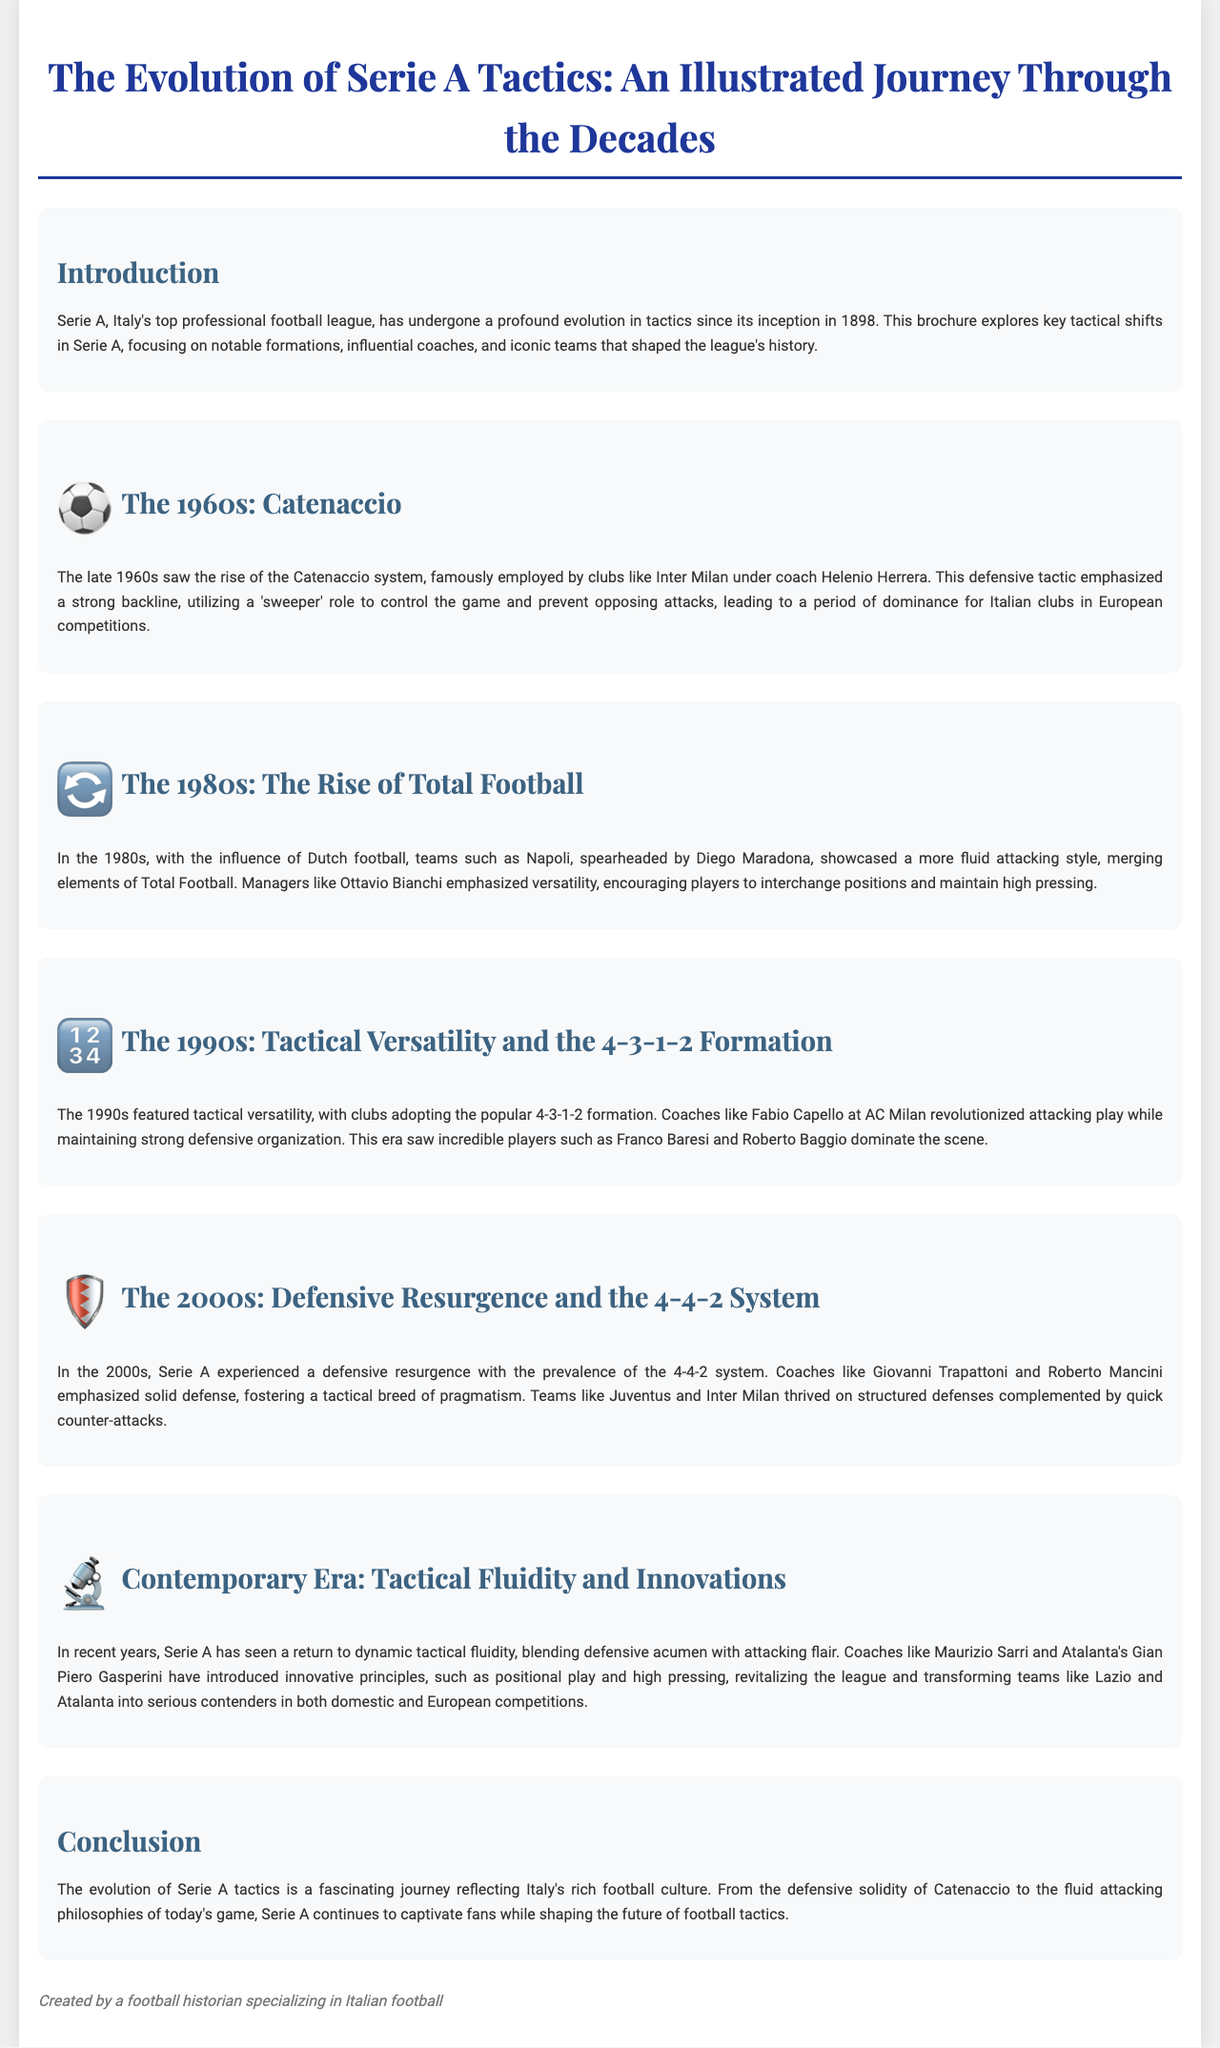What tactic rose in the 1960s? The document states that the Catenaccio system became prominent in the 1960s.
Answer: Catenaccio Which influential coach is associated with Catenaccio? The document mentions Helenio Herrera as the coach who famously employed the Catenaccio system at Inter Milan.
Answer: Helenio Herrera What formation became popular in the 1990s? The brochure indicates that the 4-3-1-2 formation was widely adopted during the 1990s.
Answer: 4-3-1-2 Which club was spearheaded by Diego Maradona in the 1980s? Napoli is highlighted as the club that showcased a more fluid attacking style in the 1980s.
Answer: Napoli What does the contemporary era focus on in Serie A tactics? The document explains that the contemporary era emphasizes tactical fluidity and innovations.
Answer: Tactical fluidity Who introduced innovative principles in recent Serie A tactics? Maurizio Sarri and Gian Piero Gasperini are noted for introducing innovative tactical principles.
Answer: Maurizio Sarri and Gian Piero Gasperini What characteristic defined the 2000s in Serie A tactics? The document mentions a defensive resurgence as a defining characteristic of the 2000s.
Answer: Defensive resurgence What did the Catenaccio system prioritize? The document explains that Catenaccio emphasized a strong backline and the role of a sweeper to control the game.
Answer: Strong backline What transition occurred in Serie A tactics from the 1960s to the 1980s? The document describes a shift from defensive tactics to a more fluid attacking style, influenced by Dutch football.
Answer: From defensive to fluid attacking style 